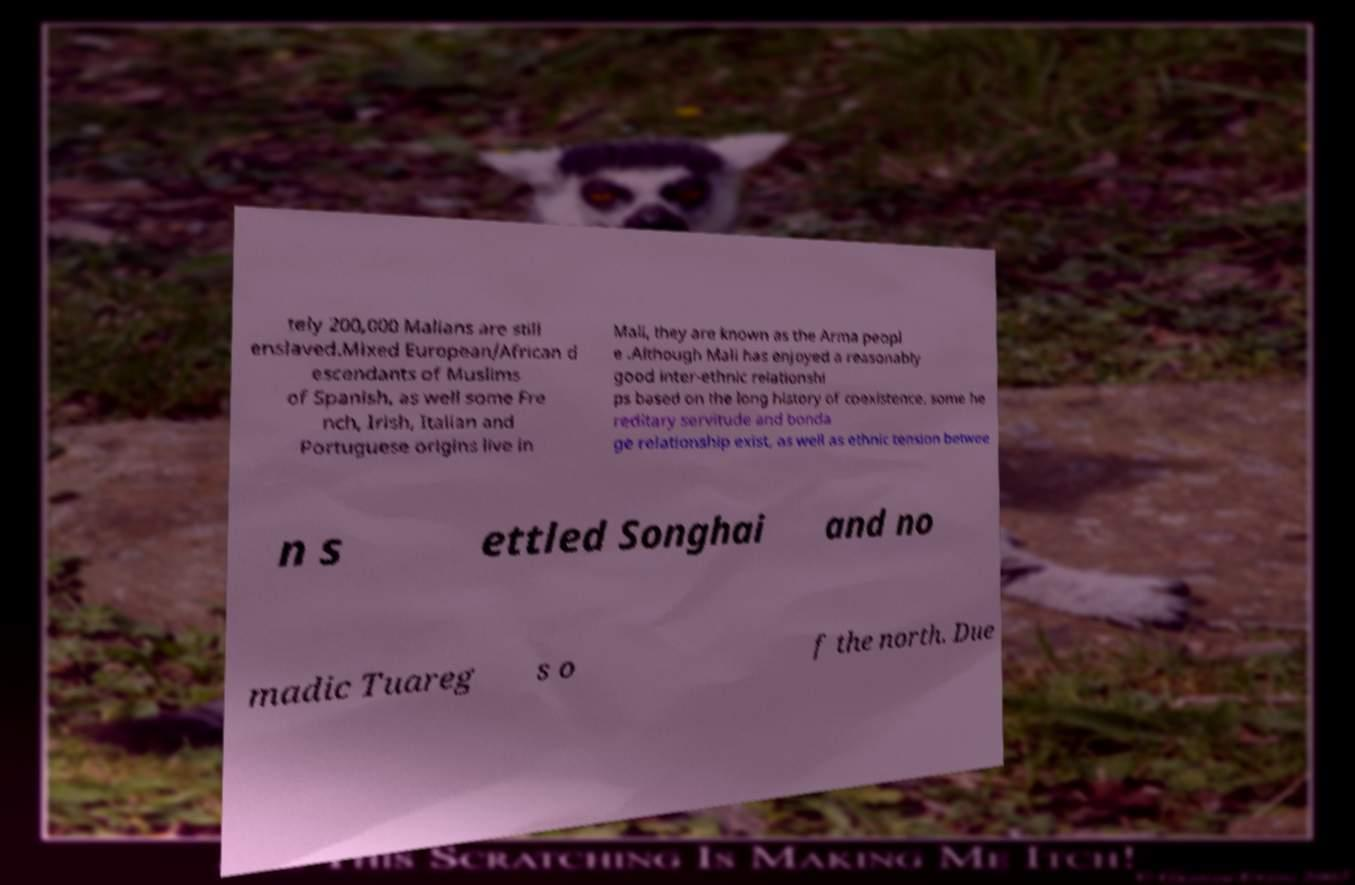Can you accurately transcribe the text from the provided image for me? tely 200,000 Malians are still enslaved.Mixed European/African d escendants of Muslims of Spanish, as well some Fre nch, Irish, Italian and Portuguese origins live in Mali, they are known as the Arma peopl e .Although Mali has enjoyed a reasonably good inter-ethnic relationshi ps based on the long history of coexistence, some he reditary servitude and bonda ge relationship exist, as well as ethnic tension betwee n s ettled Songhai and no madic Tuareg s o f the north. Due 